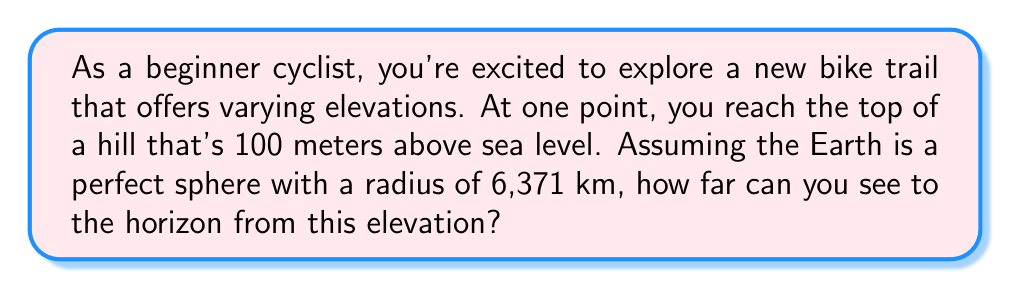Solve this math problem. To solve this problem, we'll use the following steps:

1) First, let's visualize the scenario:

[asy]
import geometry;

unitsize(1cm);

pair O = (0,0);
real R = 6;
real h = 0.1;

draw(circle(O, R));
draw((0,R)--(0,R+h));
draw(O--(R+h,R+h));

label("Earth's center", O, SW);
label("Earth's surface", (0,R), W);
label("Observer", (0,R+h), E);
label("R", (R/2,0), S);
label("h", (0,R+h/2), E);
label("d", (R+h,R+h/2), NE);

dot((0,R+h));
[/asy]

2) We can use the Pythagorean theorem to find the distance to the horizon. If we call this distance $d$, we have:

   $$(R + h)^2 = R^2 + d^2$$

   Where $R$ is the Earth's radius and $h$ is the elevation above sea level.

3) Let's substitute our known values:
   $R = 6,371,000$ meters (6,371 km)
   $h = 100$ meters

4) Now we can solve the equation:

   $$(6,371,000 + 100)^2 = 6,371,000^2 + d^2$$

5) Simplify:

   $$6,371,100^2 = 6,371,000^2 + d^2$$

6) Subtract $6,371,000^2$ from both sides:

   $$6,371,100^2 - 6,371,000^2 = d^2$$

7) Calculate:

   $$40,590,821,000 = d^2$$

8) Take the square root of both sides:

   $$d = \sqrt{40,590,821,000} \approx 35,667.5$$

Therefore, the distance to the horizon is approximately 35,667.5 meters or about 35.7 km.
Answer: The distance to the horizon from an elevation of 100 meters is approximately 35.7 km. 